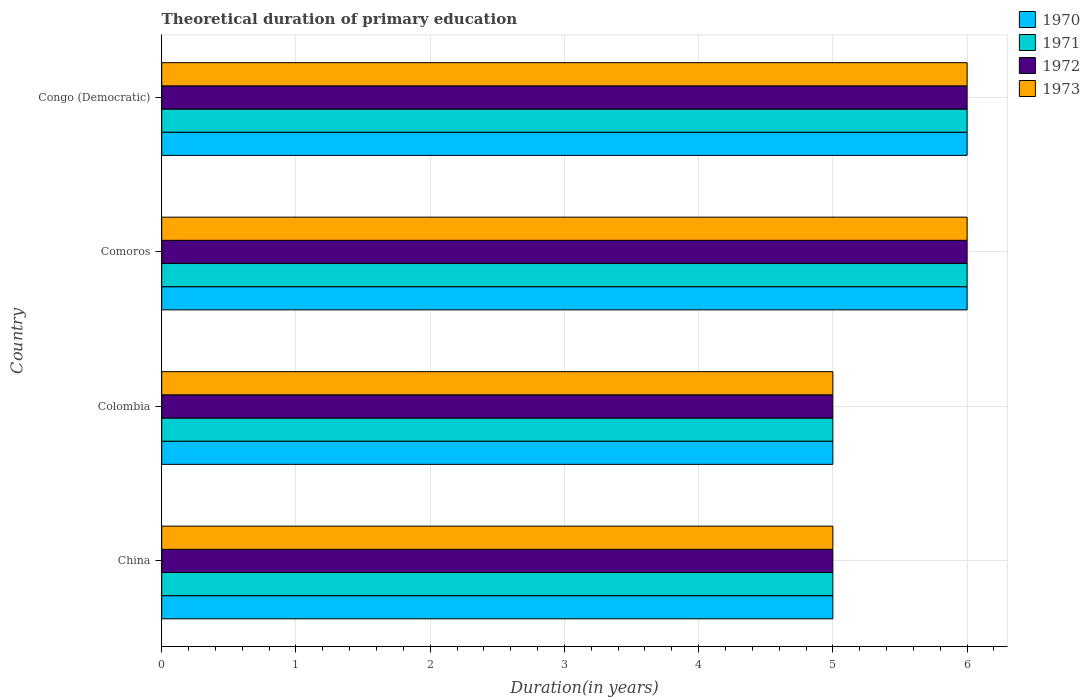How many different coloured bars are there?
Your response must be concise. 4. Are the number of bars per tick equal to the number of legend labels?
Offer a terse response. Yes. Are the number of bars on each tick of the Y-axis equal?
Give a very brief answer. Yes. What is the label of the 4th group of bars from the top?
Your answer should be compact. China. Across all countries, what is the minimum total theoretical duration of primary education in 1971?
Offer a terse response. 5. In which country was the total theoretical duration of primary education in 1970 maximum?
Keep it short and to the point. Comoros. In which country was the total theoretical duration of primary education in 1973 minimum?
Keep it short and to the point. China. What is the total total theoretical duration of primary education in 1973 in the graph?
Ensure brevity in your answer.  22. What is the difference between the total theoretical duration of primary education in 1970 in China and that in Congo (Democratic)?
Give a very brief answer. -1. What is the difference between the total theoretical duration of primary education in 1970 in Comoros and the total theoretical duration of primary education in 1972 in China?
Make the answer very short. 1. What is the average total theoretical duration of primary education in 1970 per country?
Your answer should be very brief. 5.5. In how many countries, is the total theoretical duration of primary education in 1971 greater than 3.6 years?
Your answer should be compact. 4. What is the ratio of the total theoretical duration of primary education in 1971 in China to that in Comoros?
Your response must be concise. 0.83. Is the difference between the total theoretical duration of primary education in 1970 in China and Comoros greater than the difference between the total theoretical duration of primary education in 1972 in China and Comoros?
Give a very brief answer. No. What is the difference between the highest and the lowest total theoretical duration of primary education in 1972?
Your answer should be very brief. 1. Is the sum of the total theoretical duration of primary education in 1970 in Comoros and Congo (Democratic) greater than the maximum total theoretical duration of primary education in 1971 across all countries?
Your answer should be very brief. Yes. Is it the case that in every country, the sum of the total theoretical duration of primary education in 1970 and total theoretical duration of primary education in 1973 is greater than the sum of total theoretical duration of primary education in 1971 and total theoretical duration of primary education in 1972?
Offer a very short reply. No. What does the 4th bar from the top in Colombia represents?
Your response must be concise. 1970. Is it the case that in every country, the sum of the total theoretical duration of primary education in 1971 and total theoretical duration of primary education in 1970 is greater than the total theoretical duration of primary education in 1972?
Offer a very short reply. Yes. Does the graph contain grids?
Offer a very short reply. Yes. How are the legend labels stacked?
Provide a short and direct response. Vertical. What is the title of the graph?
Your answer should be compact. Theoretical duration of primary education. Does "1988" appear as one of the legend labels in the graph?
Make the answer very short. No. What is the label or title of the X-axis?
Keep it short and to the point. Duration(in years). What is the label or title of the Y-axis?
Offer a very short reply. Country. What is the Duration(in years) of 1973 in China?
Offer a very short reply. 5. What is the Duration(in years) in 1972 in Colombia?
Make the answer very short. 5. What is the Duration(in years) in 1972 in Comoros?
Make the answer very short. 6. What is the Duration(in years) of 1973 in Comoros?
Keep it short and to the point. 6. What is the Duration(in years) of 1970 in Congo (Democratic)?
Provide a short and direct response. 6. What is the Duration(in years) of 1971 in Congo (Democratic)?
Offer a terse response. 6. What is the Duration(in years) of 1972 in Congo (Democratic)?
Your response must be concise. 6. What is the Duration(in years) of 1973 in Congo (Democratic)?
Ensure brevity in your answer.  6. Across all countries, what is the minimum Duration(in years) in 1973?
Give a very brief answer. 5. What is the total Duration(in years) of 1971 in the graph?
Give a very brief answer. 22. What is the total Duration(in years) in 1972 in the graph?
Provide a short and direct response. 22. What is the total Duration(in years) of 1973 in the graph?
Ensure brevity in your answer.  22. What is the difference between the Duration(in years) in 1973 in China and that in Colombia?
Offer a very short reply. 0. What is the difference between the Duration(in years) in 1970 in China and that in Comoros?
Offer a terse response. -1. What is the difference between the Duration(in years) in 1973 in China and that in Comoros?
Provide a short and direct response. -1. What is the difference between the Duration(in years) of 1972 in China and that in Congo (Democratic)?
Make the answer very short. -1. What is the difference between the Duration(in years) of 1973 in China and that in Congo (Democratic)?
Give a very brief answer. -1. What is the difference between the Duration(in years) in 1970 in Colombia and that in Comoros?
Offer a terse response. -1. What is the difference between the Duration(in years) in 1971 in Colombia and that in Comoros?
Offer a terse response. -1. What is the difference between the Duration(in years) in 1972 in Colombia and that in Comoros?
Make the answer very short. -1. What is the difference between the Duration(in years) of 1970 in Comoros and that in Congo (Democratic)?
Offer a very short reply. 0. What is the difference between the Duration(in years) of 1971 in Comoros and that in Congo (Democratic)?
Give a very brief answer. 0. What is the difference between the Duration(in years) in 1972 in Comoros and that in Congo (Democratic)?
Ensure brevity in your answer.  0. What is the difference between the Duration(in years) in 1973 in Comoros and that in Congo (Democratic)?
Ensure brevity in your answer.  0. What is the difference between the Duration(in years) in 1970 in China and the Duration(in years) in 1971 in Colombia?
Give a very brief answer. 0. What is the difference between the Duration(in years) of 1970 in China and the Duration(in years) of 1973 in Colombia?
Make the answer very short. 0. What is the difference between the Duration(in years) of 1971 in China and the Duration(in years) of 1973 in Colombia?
Offer a terse response. 0. What is the difference between the Duration(in years) of 1972 in China and the Duration(in years) of 1973 in Colombia?
Make the answer very short. 0. What is the difference between the Duration(in years) of 1970 in China and the Duration(in years) of 1971 in Comoros?
Ensure brevity in your answer.  -1. What is the difference between the Duration(in years) of 1970 in China and the Duration(in years) of 1973 in Comoros?
Provide a succinct answer. -1. What is the difference between the Duration(in years) in 1971 in China and the Duration(in years) in 1972 in Comoros?
Provide a short and direct response. -1. What is the difference between the Duration(in years) of 1972 in China and the Duration(in years) of 1973 in Comoros?
Offer a very short reply. -1. What is the difference between the Duration(in years) of 1970 in China and the Duration(in years) of 1971 in Congo (Democratic)?
Provide a short and direct response. -1. What is the difference between the Duration(in years) in 1971 in China and the Duration(in years) in 1973 in Congo (Democratic)?
Your answer should be very brief. -1. What is the difference between the Duration(in years) of 1972 in Colombia and the Duration(in years) of 1973 in Comoros?
Your answer should be compact. -1. What is the difference between the Duration(in years) in 1970 in Colombia and the Duration(in years) in 1971 in Congo (Democratic)?
Provide a succinct answer. -1. What is the difference between the Duration(in years) of 1970 in Colombia and the Duration(in years) of 1972 in Congo (Democratic)?
Ensure brevity in your answer.  -1. What is the difference between the Duration(in years) in 1972 in Colombia and the Duration(in years) in 1973 in Congo (Democratic)?
Provide a succinct answer. -1. What is the difference between the Duration(in years) in 1970 in Comoros and the Duration(in years) in 1973 in Congo (Democratic)?
Ensure brevity in your answer.  0. What is the difference between the Duration(in years) of 1971 in Comoros and the Duration(in years) of 1972 in Congo (Democratic)?
Make the answer very short. 0. What is the difference between the Duration(in years) of 1972 in Comoros and the Duration(in years) of 1973 in Congo (Democratic)?
Provide a short and direct response. 0. What is the average Duration(in years) in 1971 per country?
Your answer should be very brief. 5.5. What is the average Duration(in years) of 1972 per country?
Provide a succinct answer. 5.5. What is the difference between the Duration(in years) of 1970 and Duration(in years) of 1972 in China?
Offer a terse response. 0. What is the difference between the Duration(in years) in 1970 and Duration(in years) in 1973 in China?
Keep it short and to the point. 0. What is the difference between the Duration(in years) in 1971 and Duration(in years) in 1972 in China?
Make the answer very short. 0. What is the difference between the Duration(in years) in 1972 and Duration(in years) in 1973 in China?
Provide a succinct answer. 0. What is the difference between the Duration(in years) in 1970 and Duration(in years) in 1972 in Colombia?
Make the answer very short. 0. What is the difference between the Duration(in years) of 1970 and Duration(in years) of 1973 in Colombia?
Offer a very short reply. 0. What is the difference between the Duration(in years) in 1971 and Duration(in years) in 1972 in Colombia?
Offer a very short reply. 0. What is the difference between the Duration(in years) in 1971 and Duration(in years) in 1973 in Colombia?
Offer a terse response. 0. What is the difference between the Duration(in years) of 1970 and Duration(in years) of 1973 in Comoros?
Make the answer very short. 0. What is the difference between the Duration(in years) in 1971 and Duration(in years) in 1972 in Comoros?
Make the answer very short. 0. What is the difference between the Duration(in years) of 1972 and Duration(in years) of 1973 in Congo (Democratic)?
Keep it short and to the point. 0. What is the ratio of the Duration(in years) of 1971 in China to that in Colombia?
Keep it short and to the point. 1. What is the ratio of the Duration(in years) of 1972 in China to that in Colombia?
Offer a very short reply. 1. What is the ratio of the Duration(in years) of 1970 in China to that in Comoros?
Offer a very short reply. 0.83. What is the ratio of the Duration(in years) in 1971 in China to that in Comoros?
Your answer should be compact. 0.83. What is the ratio of the Duration(in years) of 1972 in China to that in Comoros?
Your answer should be compact. 0.83. What is the ratio of the Duration(in years) in 1970 in China to that in Congo (Democratic)?
Provide a succinct answer. 0.83. What is the ratio of the Duration(in years) in 1973 in China to that in Congo (Democratic)?
Provide a short and direct response. 0.83. What is the ratio of the Duration(in years) in 1971 in Colombia to that in Comoros?
Offer a terse response. 0.83. What is the ratio of the Duration(in years) in 1973 in Colombia to that in Comoros?
Offer a very short reply. 0.83. What is the ratio of the Duration(in years) in 1971 in Colombia to that in Congo (Democratic)?
Offer a terse response. 0.83. What is the ratio of the Duration(in years) of 1972 in Colombia to that in Congo (Democratic)?
Keep it short and to the point. 0.83. What is the ratio of the Duration(in years) in 1970 in Comoros to that in Congo (Democratic)?
Provide a succinct answer. 1. What is the ratio of the Duration(in years) of 1971 in Comoros to that in Congo (Democratic)?
Make the answer very short. 1. What is the ratio of the Duration(in years) of 1972 in Comoros to that in Congo (Democratic)?
Your answer should be compact. 1. What is the difference between the highest and the second highest Duration(in years) in 1971?
Ensure brevity in your answer.  0. What is the difference between the highest and the second highest Duration(in years) in 1972?
Give a very brief answer. 0. What is the difference between the highest and the second highest Duration(in years) in 1973?
Give a very brief answer. 0. What is the difference between the highest and the lowest Duration(in years) in 1970?
Your answer should be compact. 1. What is the difference between the highest and the lowest Duration(in years) in 1971?
Provide a short and direct response. 1. What is the difference between the highest and the lowest Duration(in years) in 1972?
Give a very brief answer. 1. 